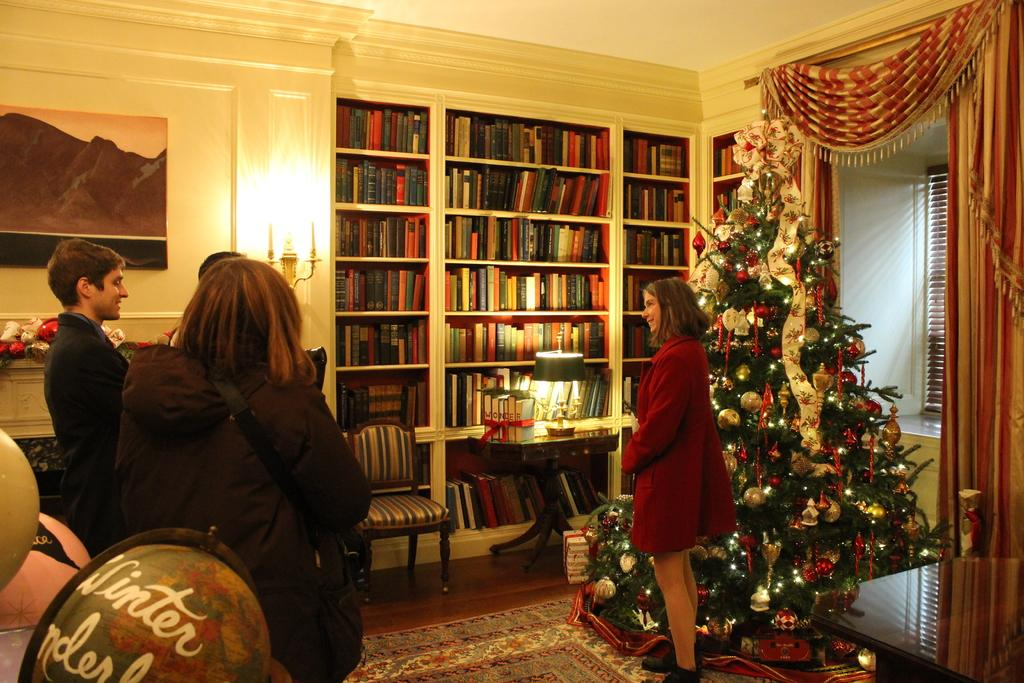Who is present in the image? There is a woman in the image. What is the woman standing near? The woman is standing near a Christmas tree. What other objects can be seen in the image? There is a bookshelf in the image. How many people are present in the image? There are three people standing in the image. What can be used to provide illumination in the image? There is a light visible in the image. What type of prison is depicted in the image? There is no prison present in the image; it features a woman standing near a Christmas tree. What selection process is being shown in the image? There is no selection process depicted in the image; it shows a woman and two other people standing near a Christmas tree and a bookshelf. 